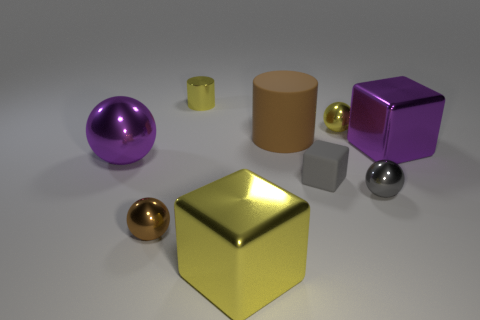Are there the same number of big things left of the large brown rubber object and big purple metallic objects?
Your answer should be very brief. Yes. What is the shape of the brown metal thing that is the same size as the metallic cylinder?
Your response must be concise. Sphere. What number of other things are there of the same shape as the large brown thing?
Your response must be concise. 1. Do the gray rubber block and the brown thing behind the tiny gray block have the same size?
Make the answer very short. No. What number of objects are cubes right of the big brown rubber thing or large purple blocks?
Your answer should be very brief. 2. The brown thing behind the big sphere has what shape?
Provide a succinct answer. Cylinder. Are there the same number of small cubes that are on the left side of the large metal sphere and big brown rubber objects that are in front of the small block?
Provide a short and direct response. Yes. There is a object that is on the left side of the tiny gray rubber cube and behind the brown matte cylinder; what is its color?
Provide a short and direct response. Yellow. What is the brown object that is behind the cube on the right side of the small yellow sphere made of?
Ensure brevity in your answer.  Rubber. Do the yellow ball and the shiny cylinder have the same size?
Keep it short and to the point. Yes. 